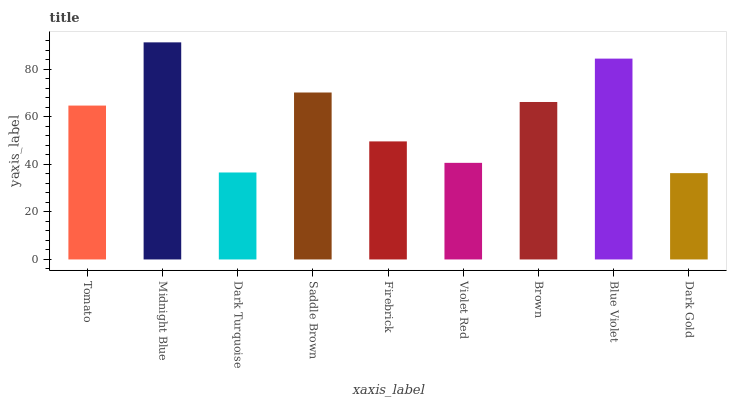Is Dark Gold the minimum?
Answer yes or no. Yes. Is Midnight Blue the maximum?
Answer yes or no. Yes. Is Dark Turquoise the minimum?
Answer yes or no. No. Is Dark Turquoise the maximum?
Answer yes or no. No. Is Midnight Blue greater than Dark Turquoise?
Answer yes or no. Yes. Is Dark Turquoise less than Midnight Blue?
Answer yes or no. Yes. Is Dark Turquoise greater than Midnight Blue?
Answer yes or no. No. Is Midnight Blue less than Dark Turquoise?
Answer yes or no. No. Is Tomato the high median?
Answer yes or no. Yes. Is Tomato the low median?
Answer yes or no. Yes. Is Dark Turquoise the high median?
Answer yes or no. No. Is Firebrick the low median?
Answer yes or no. No. 